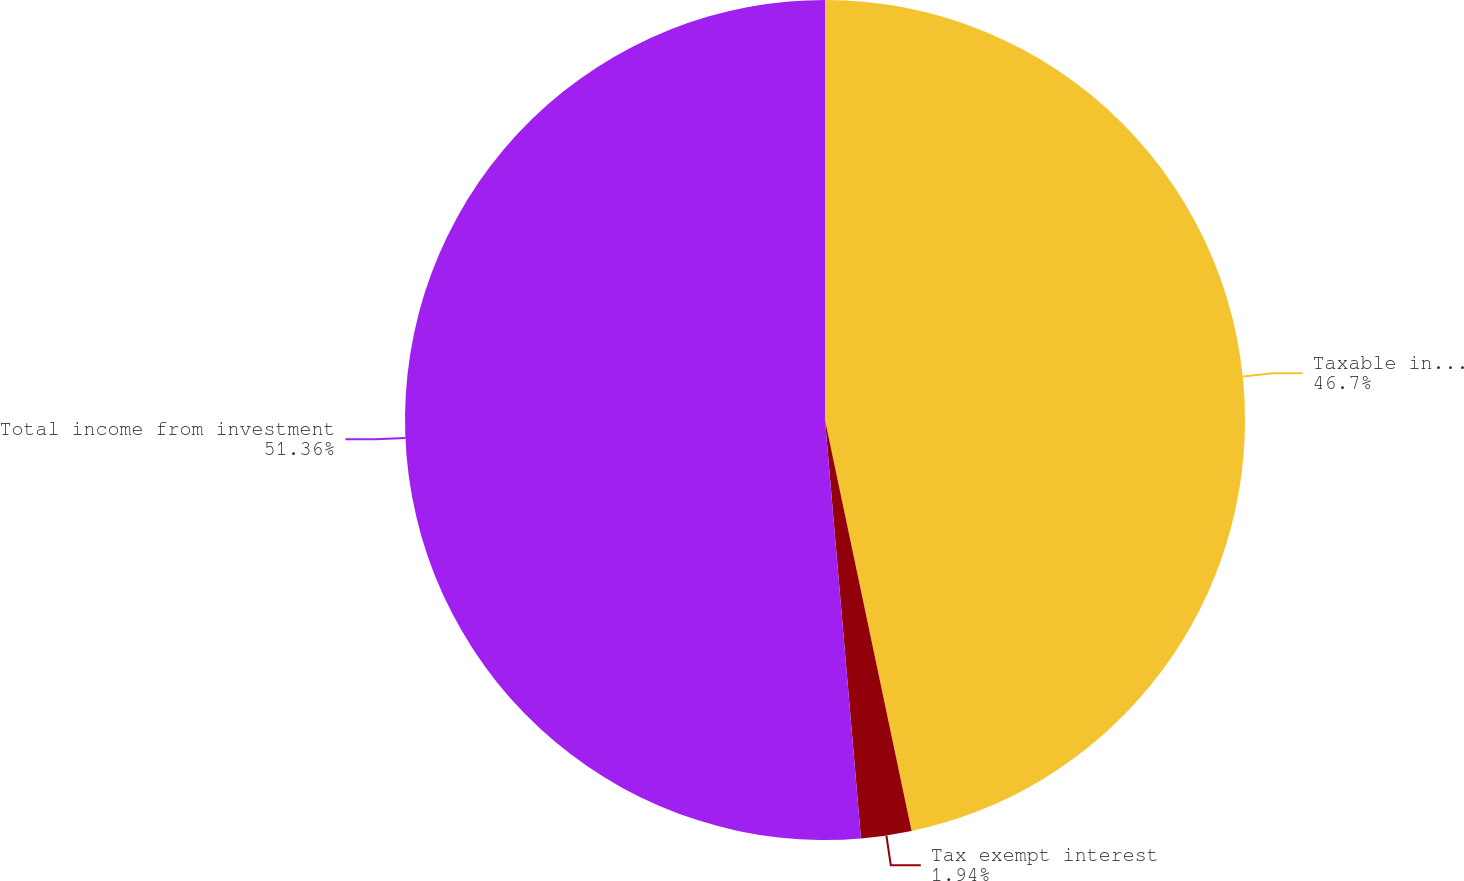Convert chart. <chart><loc_0><loc_0><loc_500><loc_500><pie_chart><fcel>Taxable interest<fcel>Tax exempt interest<fcel>Total income from investment<nl><fcel>46.7%<fcel>1.94%<fcel>51.37%<nl></chart> 